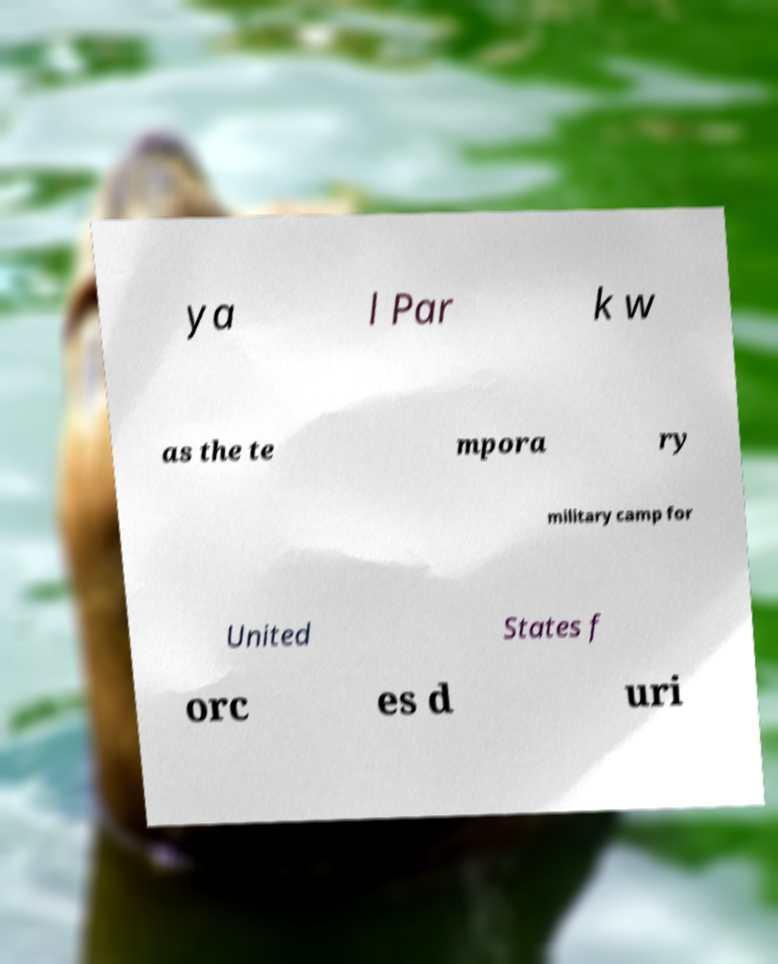I need the written content from this picture converted into text. Can you do that? ya l Par k w as the te mpora ry military camp for United States f orc es d uri 